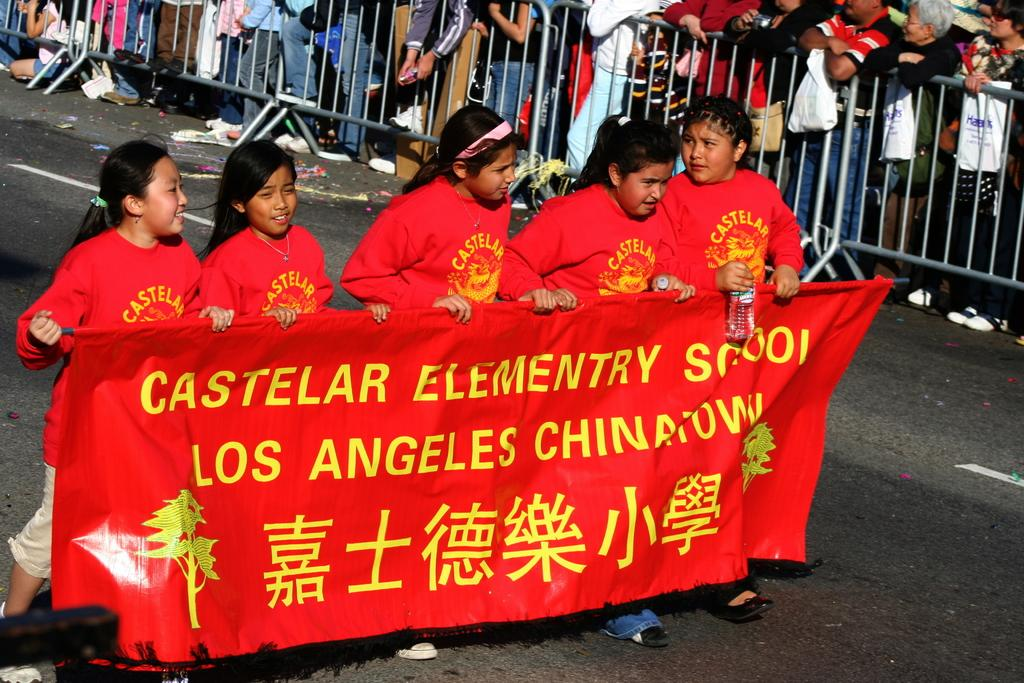What are the people in the image doing? The people in the image are walking. What are the people holding while walking? The people are holding a banner with text on it. What can be seen in the background of the image? There is a railing in the background of the image. Who is present behind the railing? There are spectators behind the railing. What type of copper material is present in the alley in the image? There is no alley or copper material present in the image. 